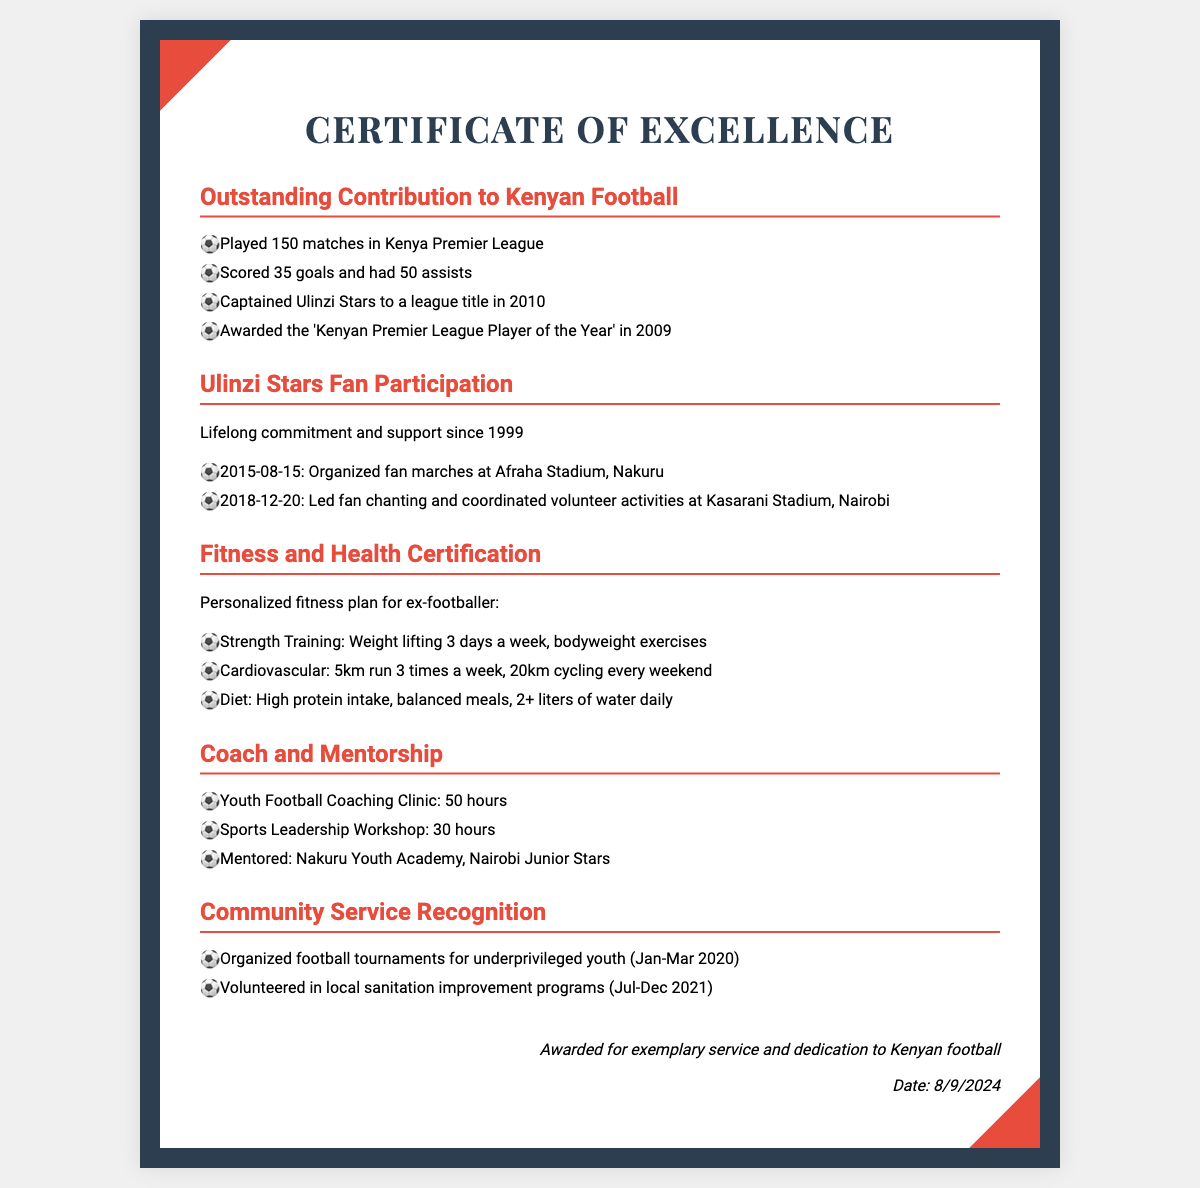What is the title of the first section? The title of the first section focuses on contributions to Kenyan football, as indicated in the heading.
Answer: Outstanding Contribution to Kenyan Football How many matches did you play in the Kenya Premier League? The document lists a specific number of matches played by the individual in this league.
Answer: 150 matches What year did you captain Ulinzi Stars to a league title? The document provides a specific year related to a significant achievement linked to Ulinzi Stars.
Answer: 2010 What is the total number of hours spent in youth football coaching clinics? The document specifies the hours dedicated to the youth football coaching clinic, along with other coaching activities.
Answer: 50 hours Which event involved organizing fan marches? The document mentions a specific event date and activity related to fan participation for Ulinzi Stars.
Answer: 2015-08-15 What type of training is suggested for strength? The document outlines specific fitness training suggestions, including a type of exercise for strengthening.
Answer: Weight lifting What activity is mentioned regarding community service in 2020? The document highlights a specific type of community service event organized in early 2020.
Answer: Organized football tournaments What date is provided at the bottom of the certificate? The document includes a date that reflects the award date at the bottom of the certificate.
Answer: Current date 